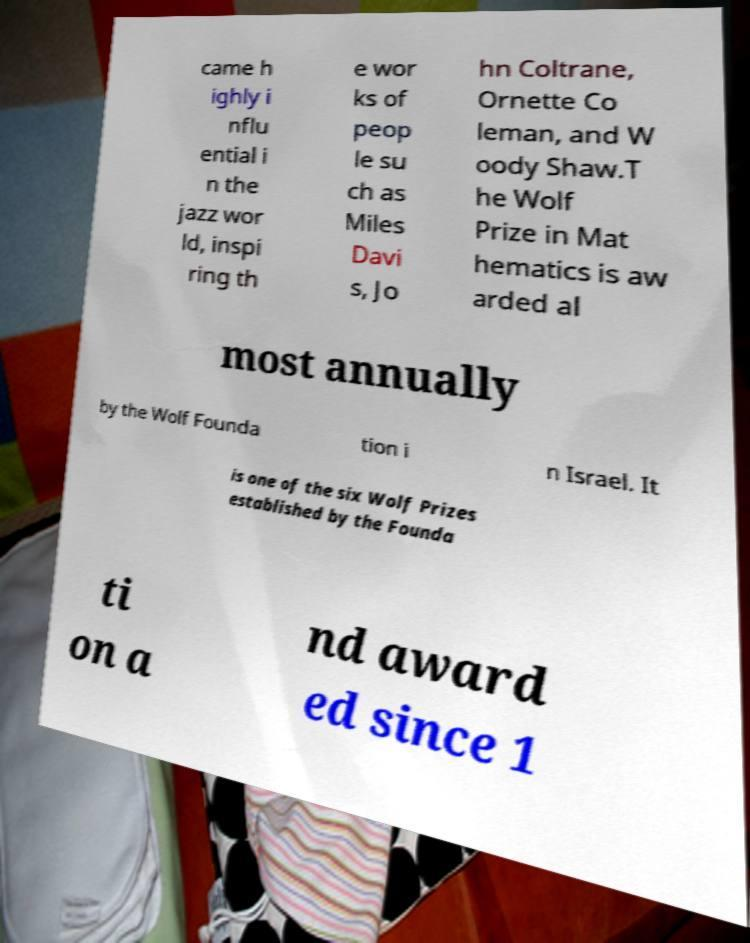For documentation purposes, I need the text within this image transcribed. Could you provide that? came h ighly i nflu ential i n the jazz wor ld, inspi ring th e wor ks of peop le su ch as Miles Davi s, Jo hn Coltrane, Ornette Co leman, and W oody Shaw.T he Wolf Prize in Mat hematics is aw arded al most annually by the Wolf Founda tion i n Israel. It is one of the six Wolf Prizes established by the Founda ti on a nd award ed since 1 